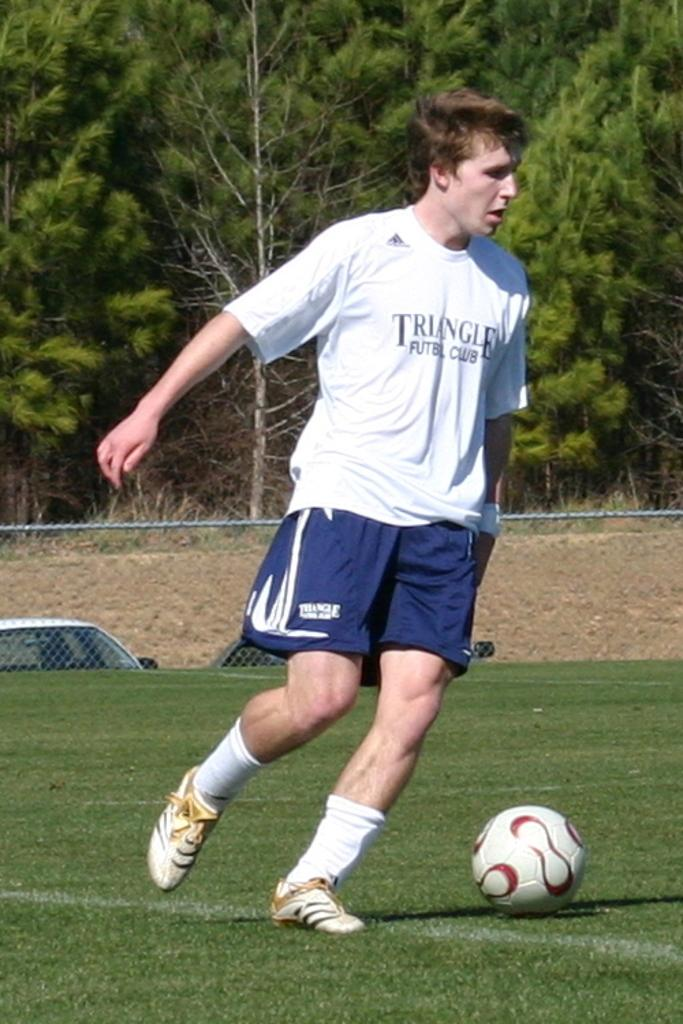<image>
Offer a succinct explanation of the picture presented. A man in a Triangle Club shirt is next to a soccer ball. 